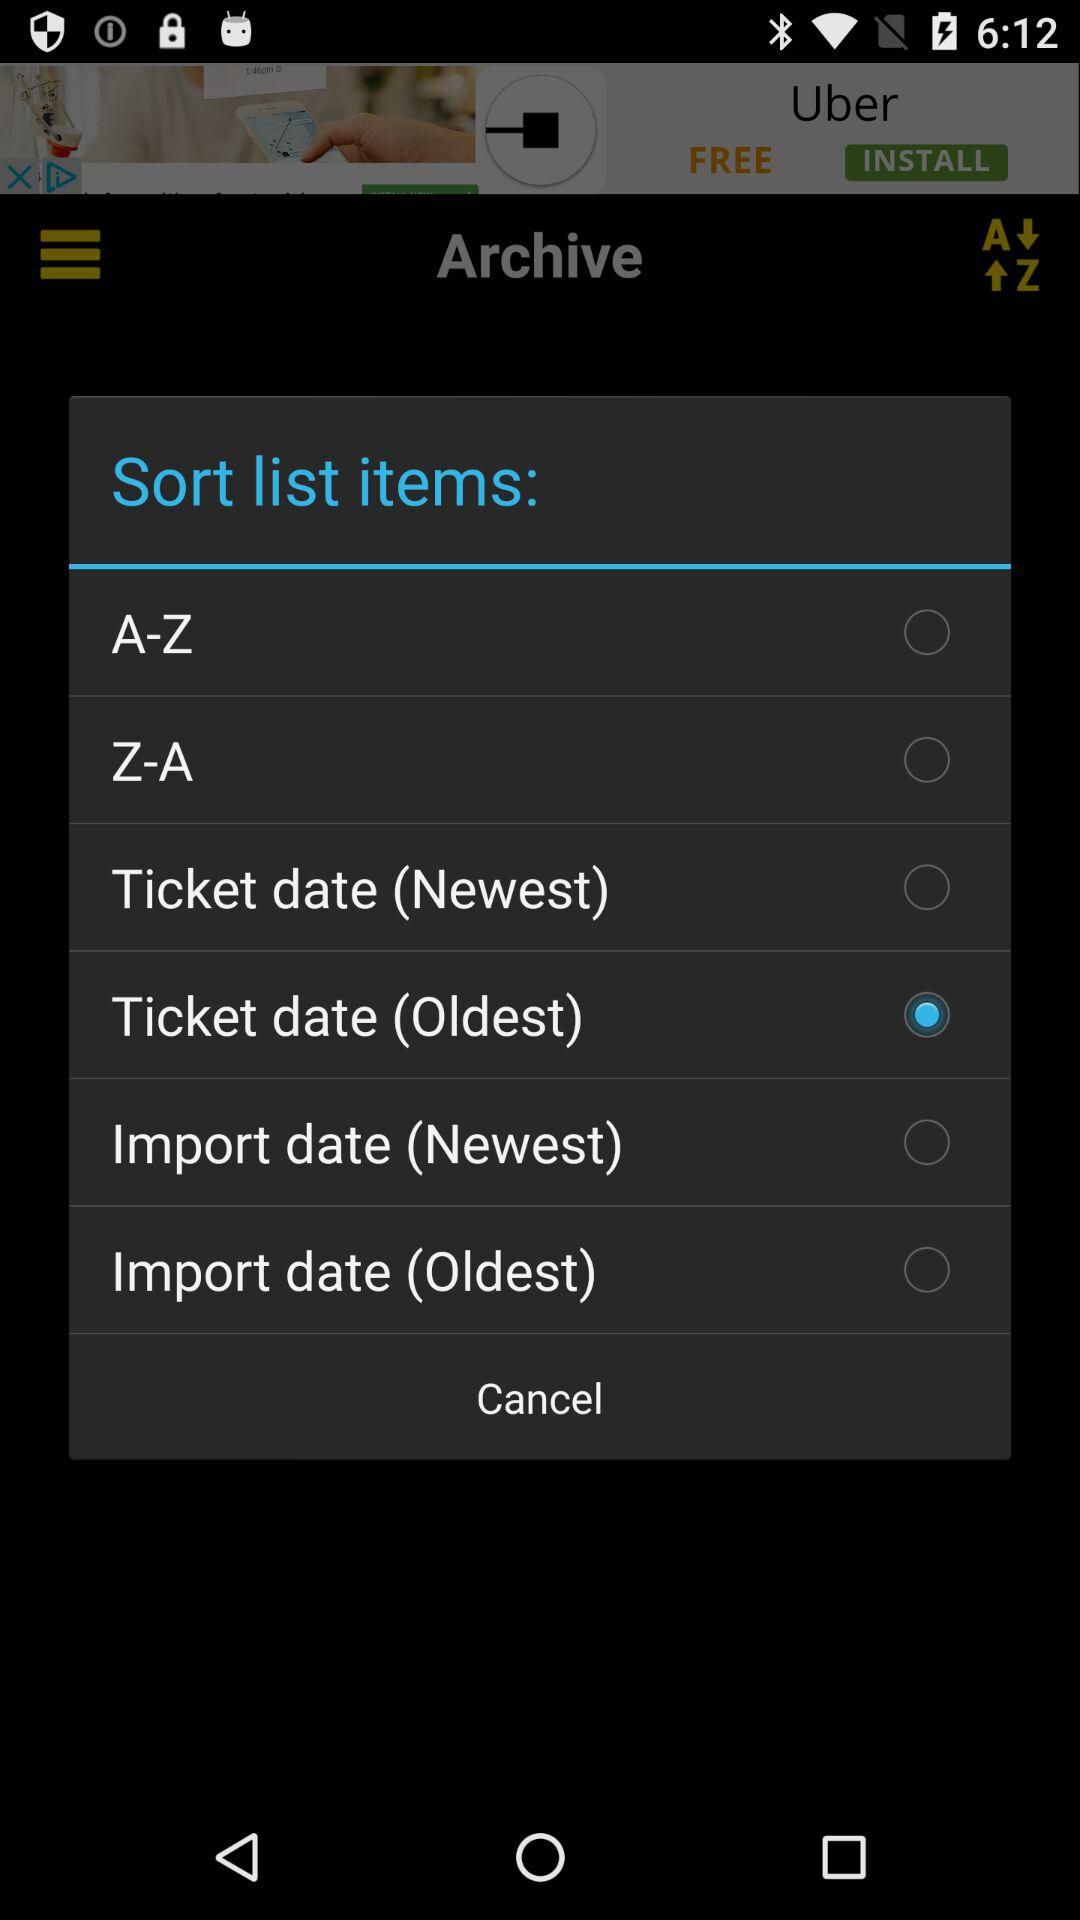Who is this application powered by?
When the provided information is insufficient, respond with <no answer>. <no answer> 